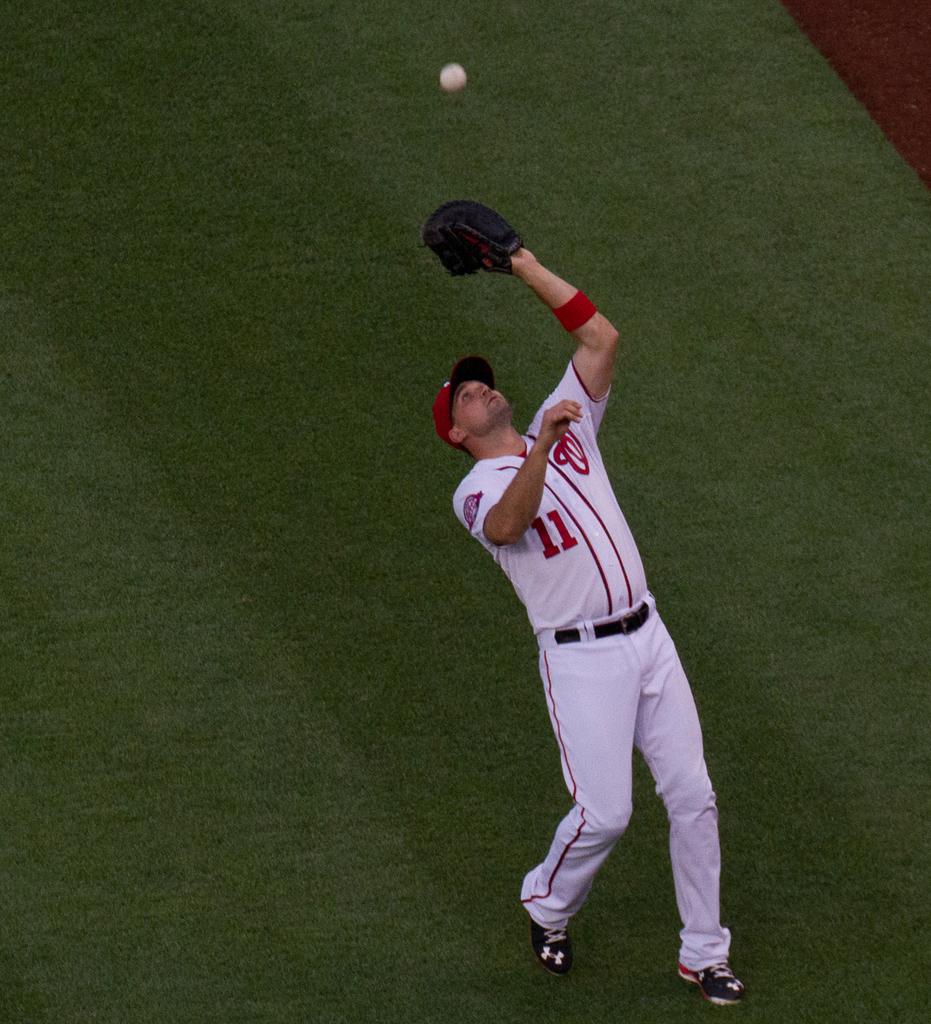What player number is this man?
Provide a succinct answer. 11. 